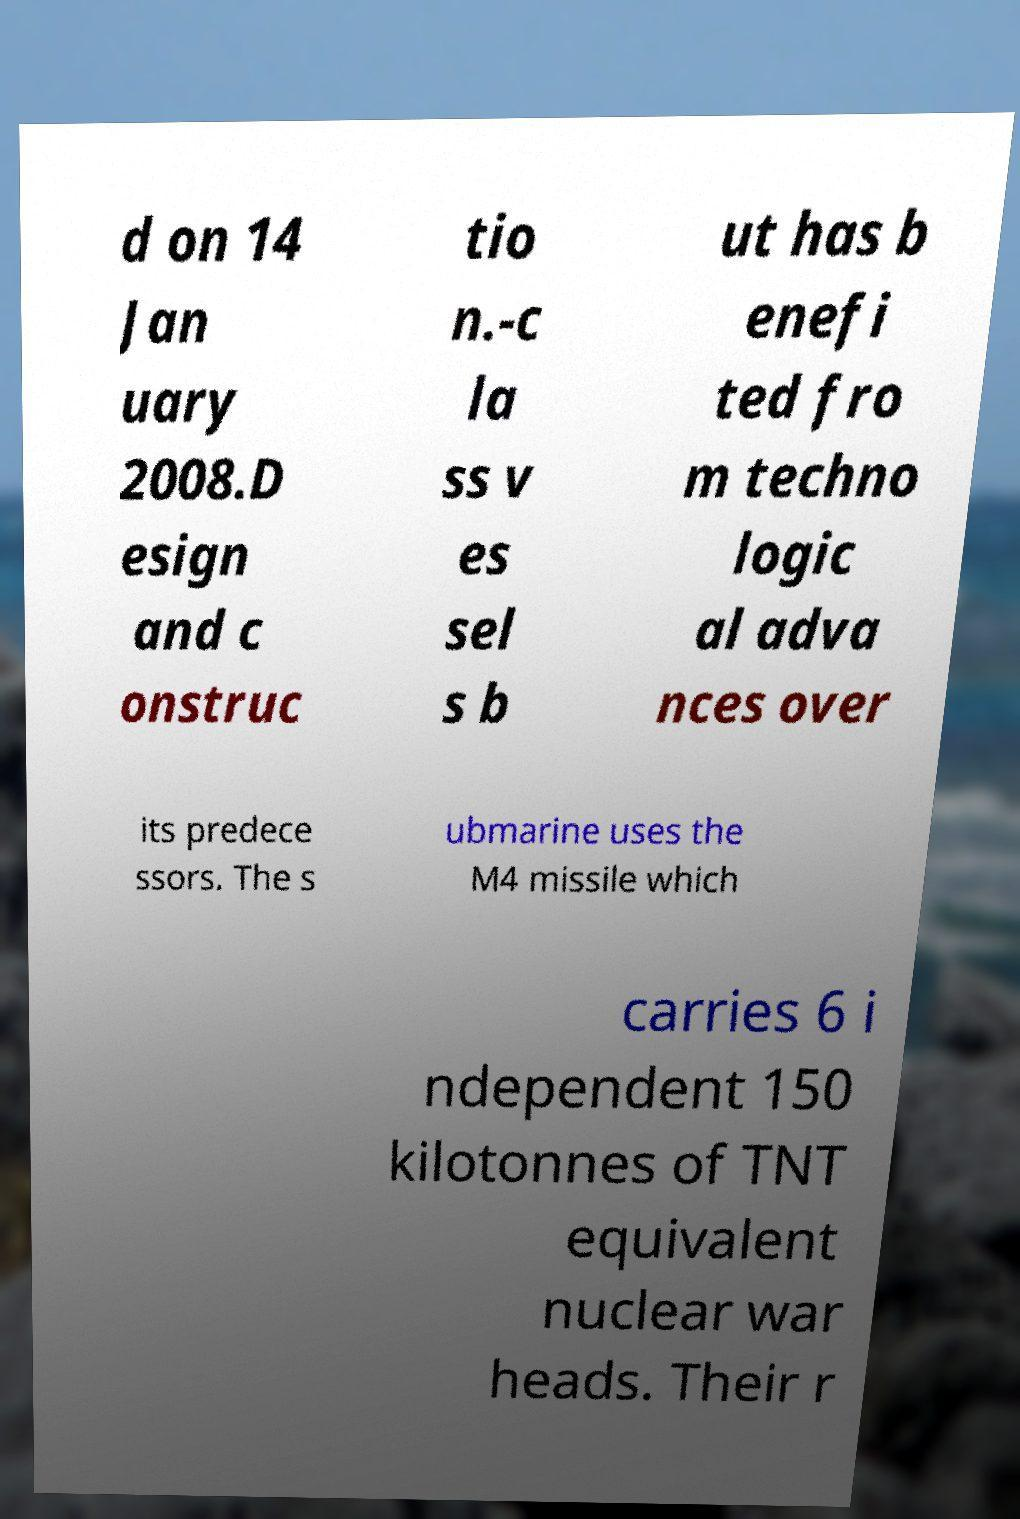Could you assist in decoding the text presented in this image and type it out clearly? d on 14 Jan uary 2008.D esign and c onstruc tio n.-c la ss v es sel s b ut has b enefi ted fro m techno logic al adva nces over its predece ssors. The s ubmarine uses the M4 missile which carries 6 i ndependent 150 kilotonnes of TNT equivalent nuclear war heads. Their r 